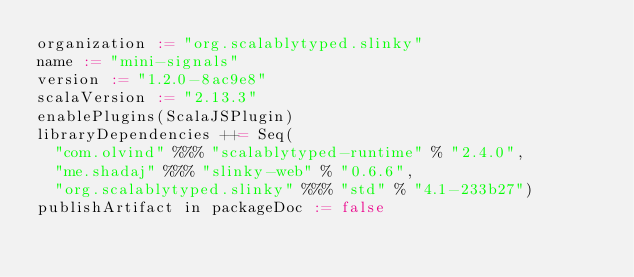<code> <loc_0><loc_0><loc_500><loc_500><_Scala_>organization := "org.scalablytyped.slinky"
name := "mini-signals"
version := "1.2.0-8ac9e8"
scalaVersion := "2.13.3"
enablePlugins(ScalaJSPlugin)
libraryDependencies ++= Seq(
  "com.olvind" %%% "scalablytyped-runtime" % "2.4.0",
  "me.shadaj" %%% "slinky-web" % "0.6.6",
  "org.scalablytyped.slinky" %%% "std" % "4.1-233b27")
publishArtifact in packageDoc := false</code> 